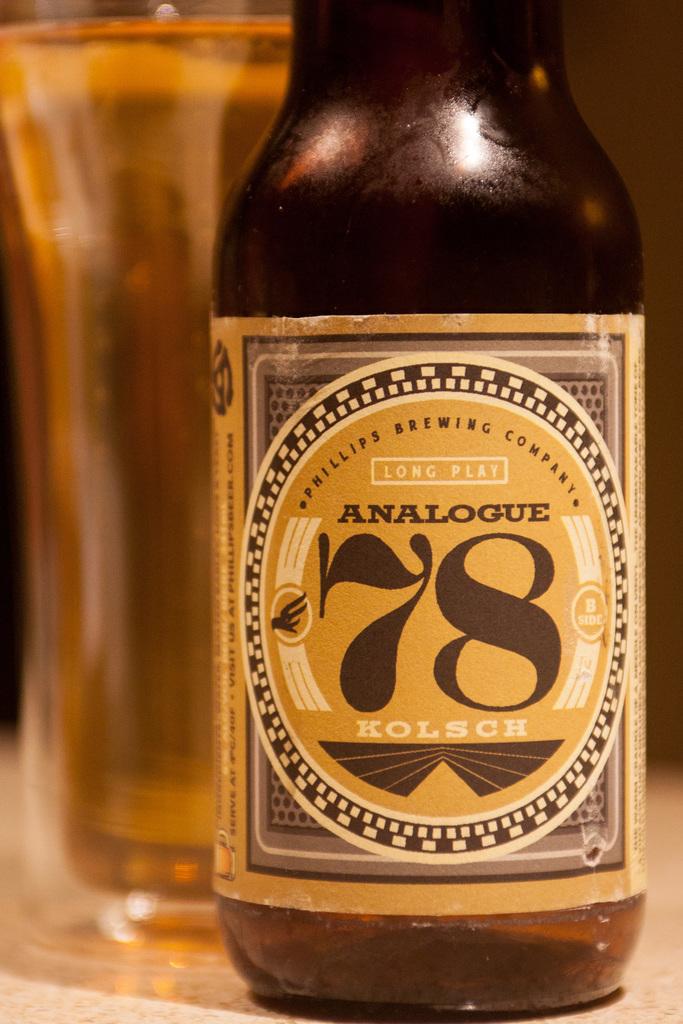What number is featured on this bottle?
Keep it short and to the point. 78. 